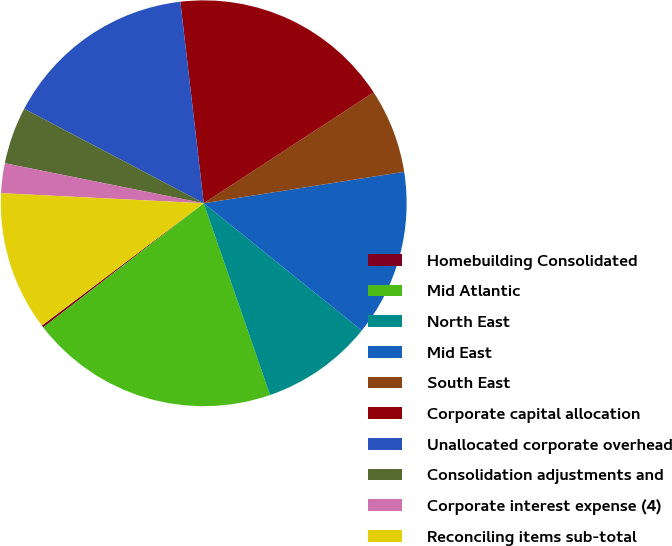Convert chart to OTSL. <chart><loc_0><loc_0><loc_500><loc_500><pie_chart><fcel>Homebuilding Consolidated<fcel>Mid Atlantic<fcel>North East<fcel>Mid East<fcel>South East<fcel>Corporate capital allocation<fcel>Unallocated corporate overhead<fcel>Consolidation adjustments and<fcel>Corporate interest expense (4)<fcel>Reconciling items sub-total<nl><fcel>0.18%<fcel>19.82%<fcel>8.91%<fcel>13.27%<fcel>6.73%<fcel>17.63%<fcel>15.45%<fcel>4.55%<fcel>2.37%<fcel>11.09%<nl></chart> 